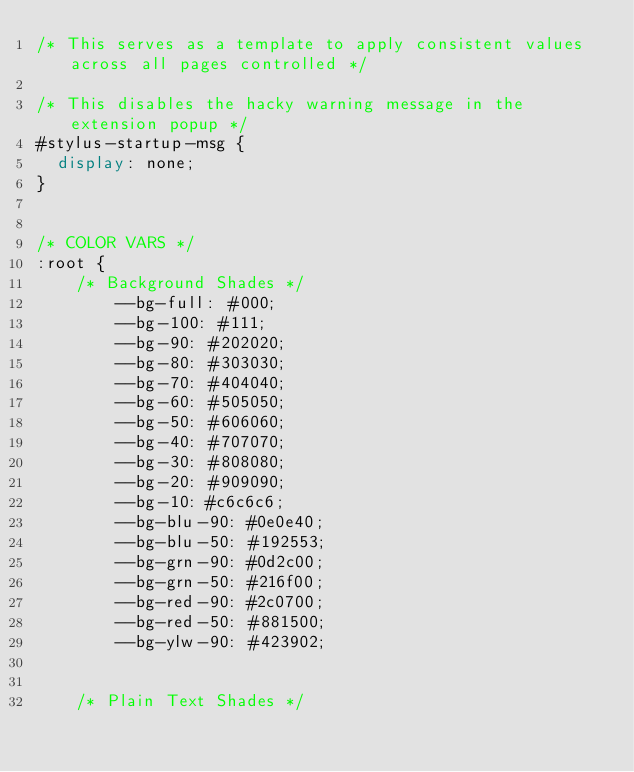<code> <loc_0><loc_0><loc_500><loc_500><_CSS_>/* This serves as a template to apply consistent values across all pages controlled */

/* This disables the hacky warning message in the extension popup */
#stylus-startup-msg {
  display: none;
}


/* COLOR VARS */
:root {
    /* Background Shades */
        --bg-full: #000;
        --bg-100: #111;
        --bg-90: #202020;
        --bg-80: #303030;
        --bg-70: #404040;
        --bg-60: #505050;
        --bg-50: #606060;
        --bg-40: #707070;
        --bg-30: #808080;
        --bg-20: #909090;
        --bg-10: #c6c6c6;
        --bg-blu-90: #0e0e40;
        --bg-blu-50: #192553;
        --bg-grn-90: #0d2c00;
        --bg-grn-50: #216f00;
        --bg-red-90: #2c0700;
        --bg-red-50: #881500;
        --bg-ylw-90: #423902;
    
    
    /* Plain Text Shades */</code> 